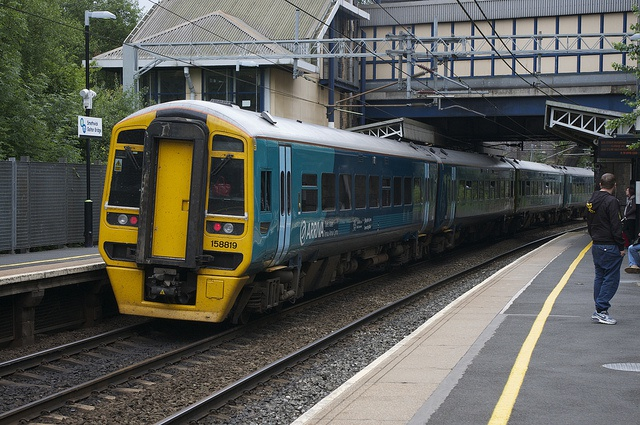Describe the objects in this image and their specific colors. I can see train in gray, black, blue, and olive tones, people in gray, black, navy, and darkblue tones, people in gray, black, and darkgray tones, and people in gray, black, navy, and darkblue tones in this image. 